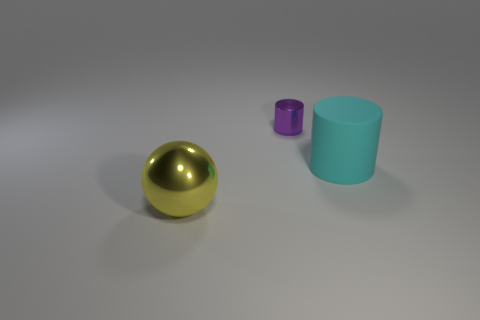Add 1 big brown rubber objects. How many objects exist? 4 Subtract all spheres. How many objects are left? 2 Subtract 0 gray spheres. How many objects are left? 3 Subtract all tiny purple things. Subtract all purple objects. How many objects are left? 1 Add 1 large cylinders. How many large cylinders are left? 2 Add 1 big cyan rubber cylinders. How many big cyan rubber cylinders exist? 2 